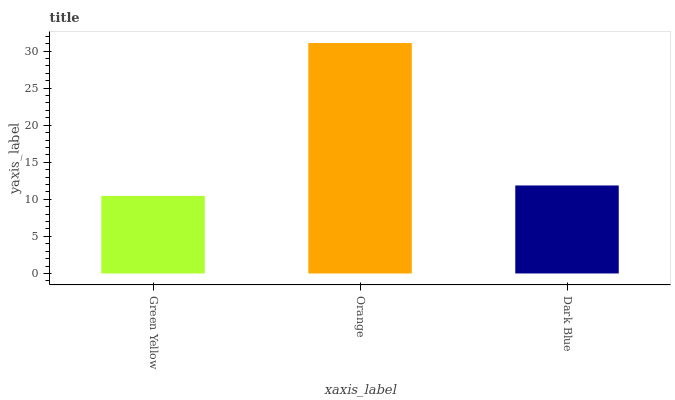Is Green Yellow the minimum?
Answer yes or no. Yes. Is Orange the maximum?
Answer yes or no. Yes. Is Dark Blue the minimum?
Answer yes or no. No. Is Dark Blue the maximum?
Answer yes or no. No. Is Orange greater than Dark Blue?
Answer yes or no. Yes. Is Dark Blue less than Orange?
Answer yes or no. Yes. Is Dark Blue greater than Orange?
Answer yes or no. No. Is Orange less than Dark Blue?
Answer yes or no. No. Is Dark Blue the high median?
Answer yes or no. Yes. Is Dark Blue the low median?
Answer yes or no. Yes. Is Green Yellow the high median?
Answer yes or no. No. Is Orange the low median?
Answer yes or no. No. 